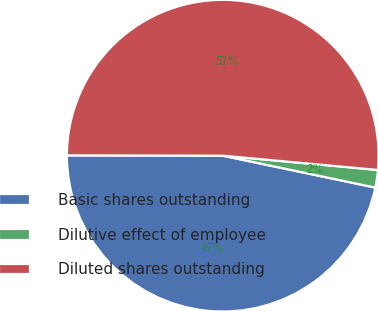<chart> <loc_0><loc_0><loc_500><loc_500><pie_chart><fcel>Basic shares outstanding<fcel>Dilutive effect of employee<fcel>Diluted shares outstanding<nl><fcel>46.75%<fcel>1.82%<fcel>51.43%<nl></chart> 